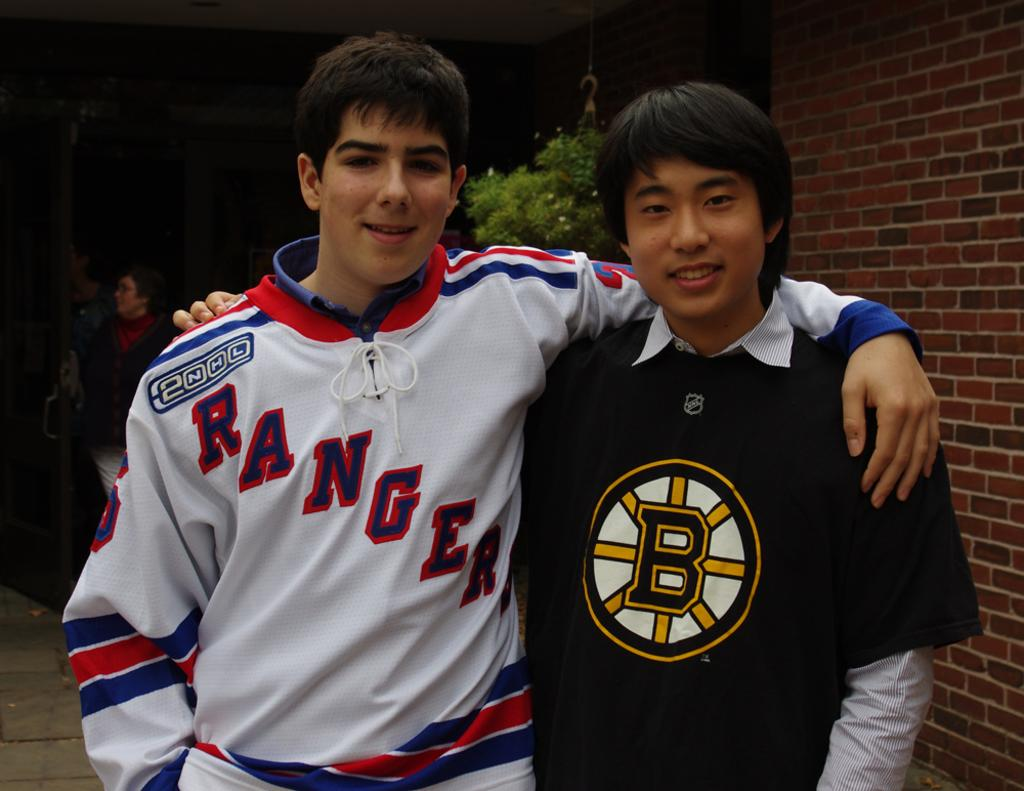<image>
Create a compact narrative representing the image presented. Young man with a white jersey that displays RANGERS on the front. 